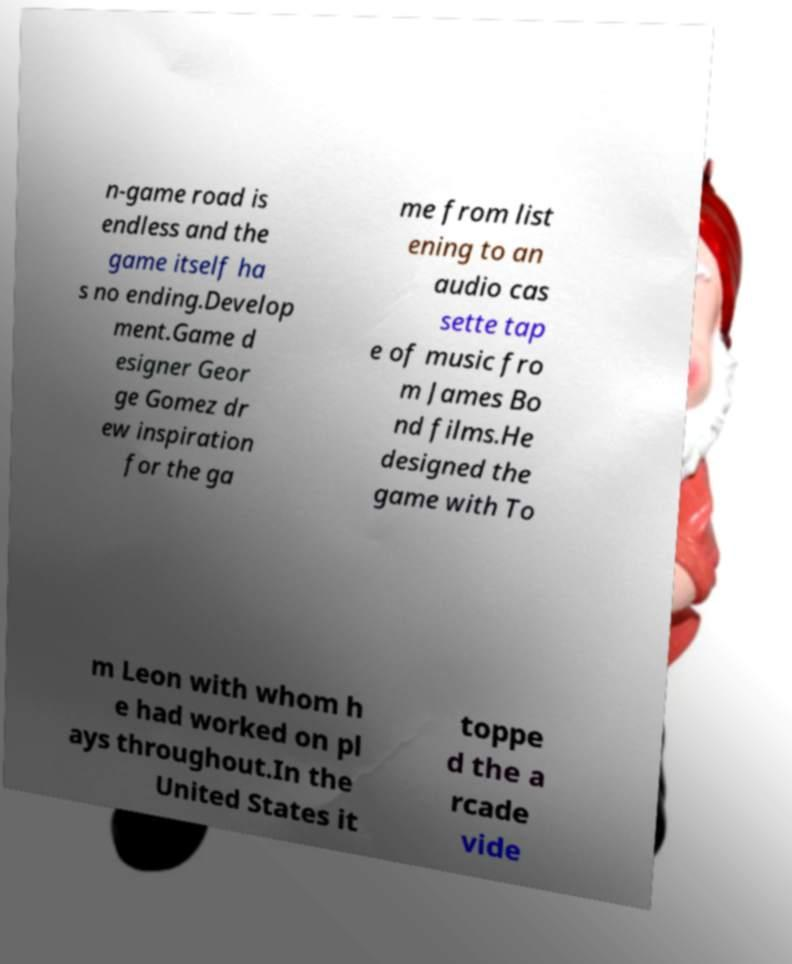Can you read and provide the text displayed in the image?This photo seems to have some interesting text. Can you extract and type it out for me? n-game road is endless and the game itself ha s no ending.Develop ment.Game d esigner Geor ge Gomez dr ew inspiration for the ga me from list ening to an audio cas sette tap e of music fro m James Bo nd films.He designed the game with To m Leon with whom h e had worked on pl ays throughout.In the United States it toppe d the a rcade vide 